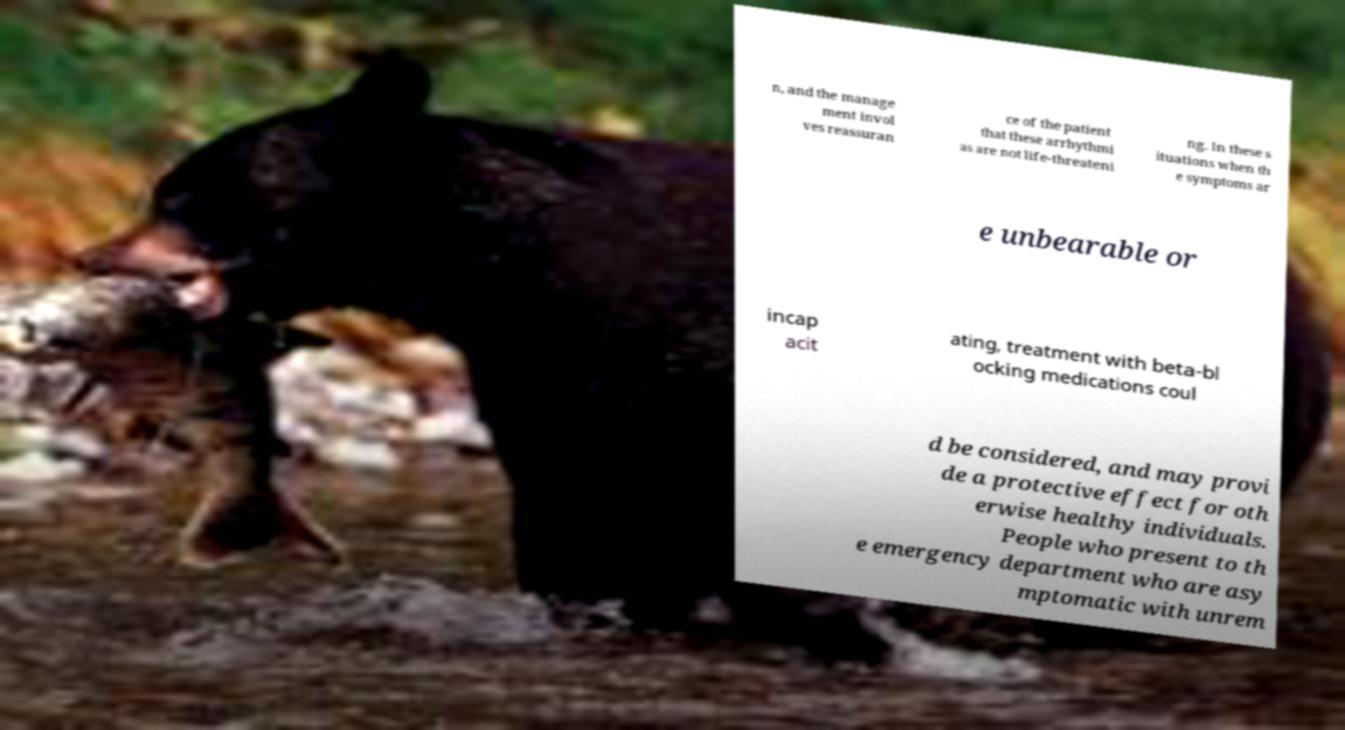Please identify and transcribe the text found in this image. n, and the manage ment invol ves reassuran ce of the patient that these arrhythmi as are not life-threateni ng. In these s ituations when th e symptoms ar e unbearable or incap acit ating, treatment with beta-bl ocking medications coul d be considered, and may provi de a protective effect for oth erwise healthy individuals. People who present to th e emergency department who are asy mptomatic with unrem 